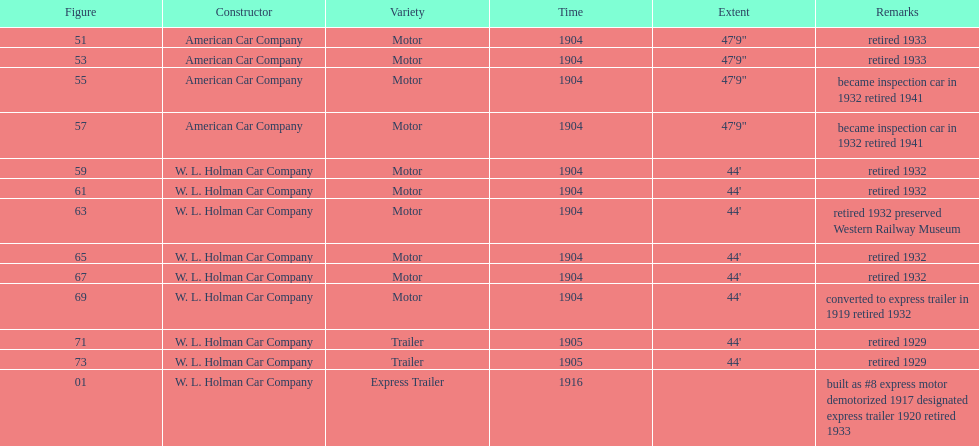Did american car company or w.l. holman car company build cars that were 44' in length? W. L. Holman Car Company. 